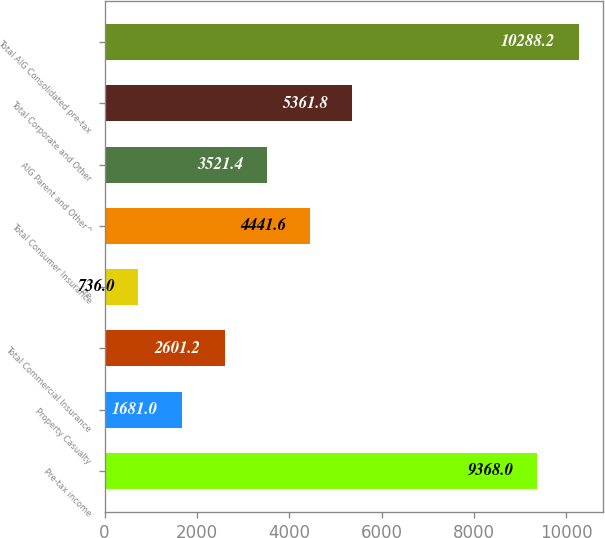<chart> <loc_0><loc_0><loc_500><loc_500><bar_chart><fcel>Pre-tax income<fcel>Property Casualty<fcel>Total Commercial Insurance<fcel>Life<fcel>Total Consumer Insurance<fcel>AIG Parent and Other^<fcel>Total Corporate and Other<fcel>Total AIG Consolidated pre-tax<nl><fcel>9368<fcel>1681<fcel>2601.2<fcel>736<fcel>4441.6<fcel>3521.4<fcel>5361.8<fcel>10288.2<nl></chart> 